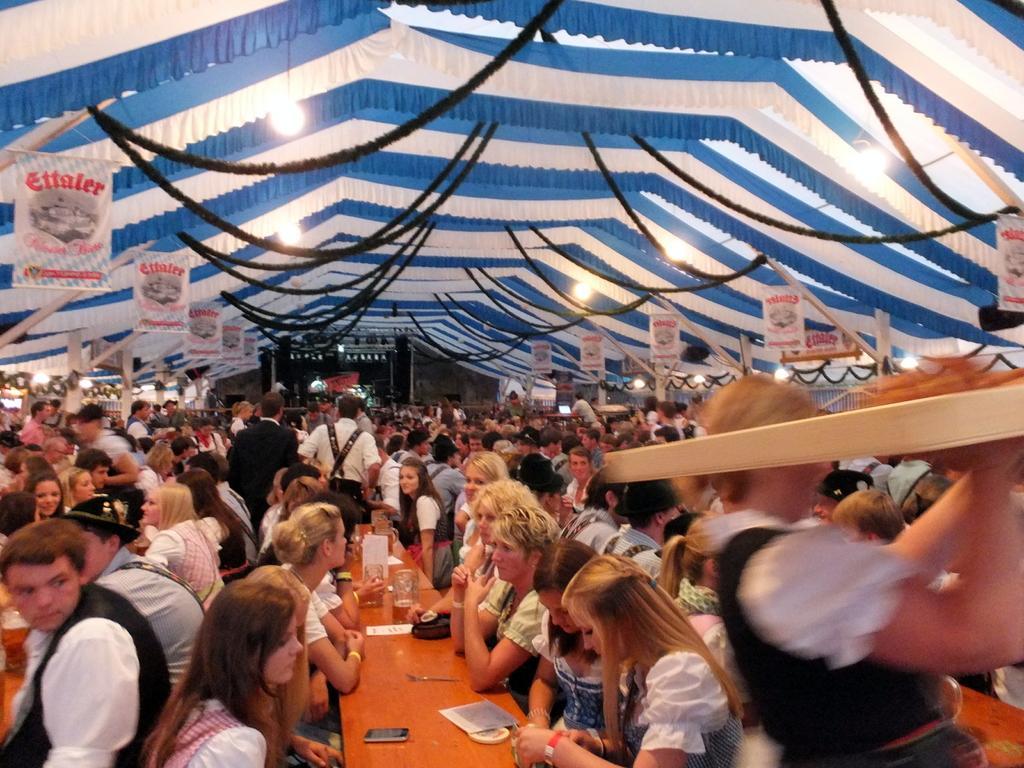Could you give a brief overview of what you see in this image? In this picture there are people and we can see glasses and objects on tables. We can see ropes, lights, tent and poles. 